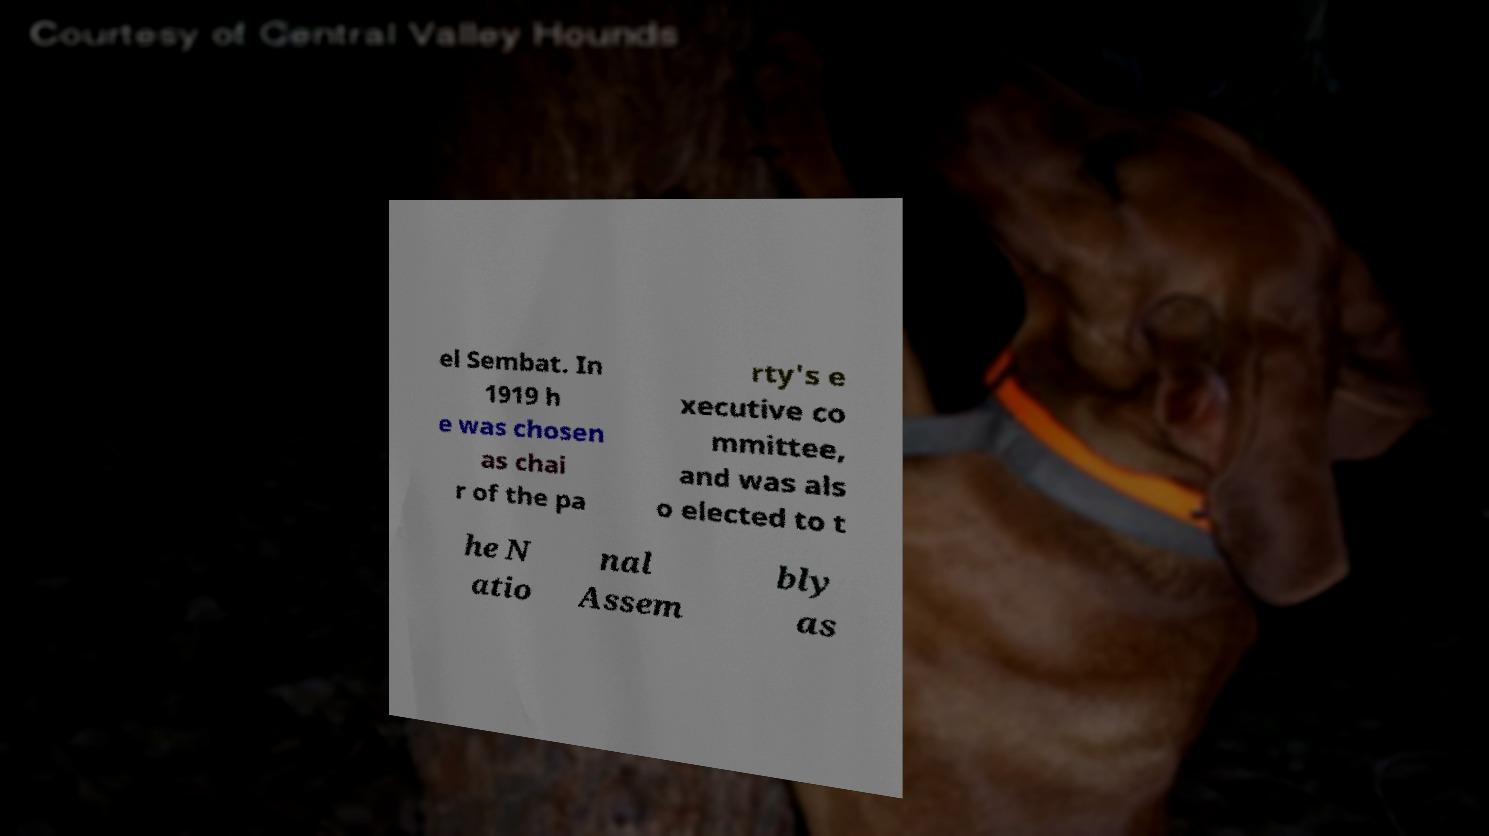I need the written content from this picture converted into text. Can you do that? el Sembat. In 1919 h e was chosen as chai r of the pa rty's e xecutive co mmittee, and was als o elected to t he N atio nal Assem bly as 